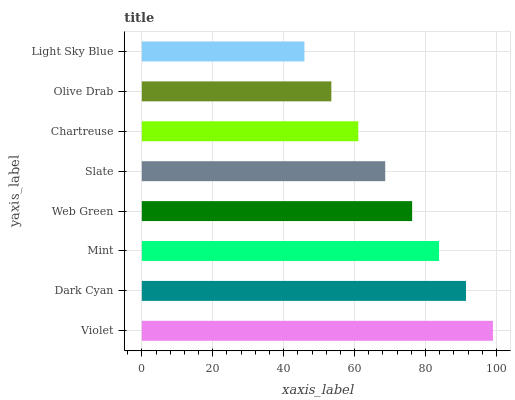Is Light Sky Blue the minimum?
Answer yes or no. Yes. Is Violet the maximum?
Answer yes or no. Yes. Is Dark Cyan the minimum?
Answer yes or no. No. Is Dark Cyan the maximum?
Answer yes or no. No. Is Violet greater than Dark Cyan?
Answer yes or no. Yes. Is Dark Cyan less than Violet?
Answer yes or no. Yes. Is Dark Cyan greater than Violet?
Answer yes or no. No. Is Violet less than Dark Cyan?
Answer yes or no. No. Is Web Green the high median?
Answer yes or no. Yes. Is Slate the low median?
Answer yes or no. Yes. Is Dark Cyan the high median?
Answer yes or no. No. Is Light Sky Blue the low median?
Answer yes or no. No. 